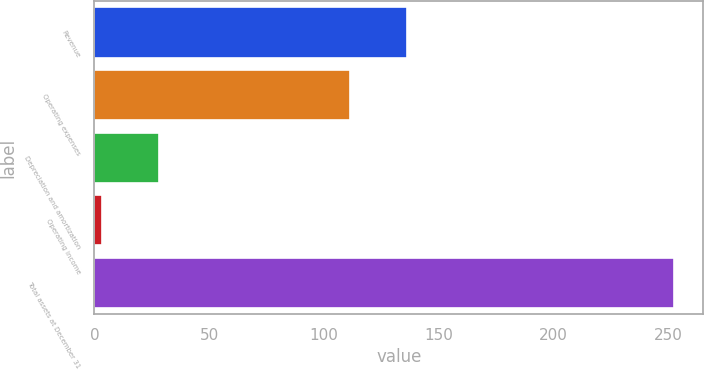Convert chart. <chart><loc_0><loc_0><loc_500><loc_500><bar_chart><fcel>Revenue<fcel>Operating expenses<fcel>Depreciation and amortization<fcel>Operating income<fcel>Total assets at December 31<nl><fcel>136.34<fcel>111.4<fcel>28.24<fcel>3.3<fcel>252.7<nl></chart> 